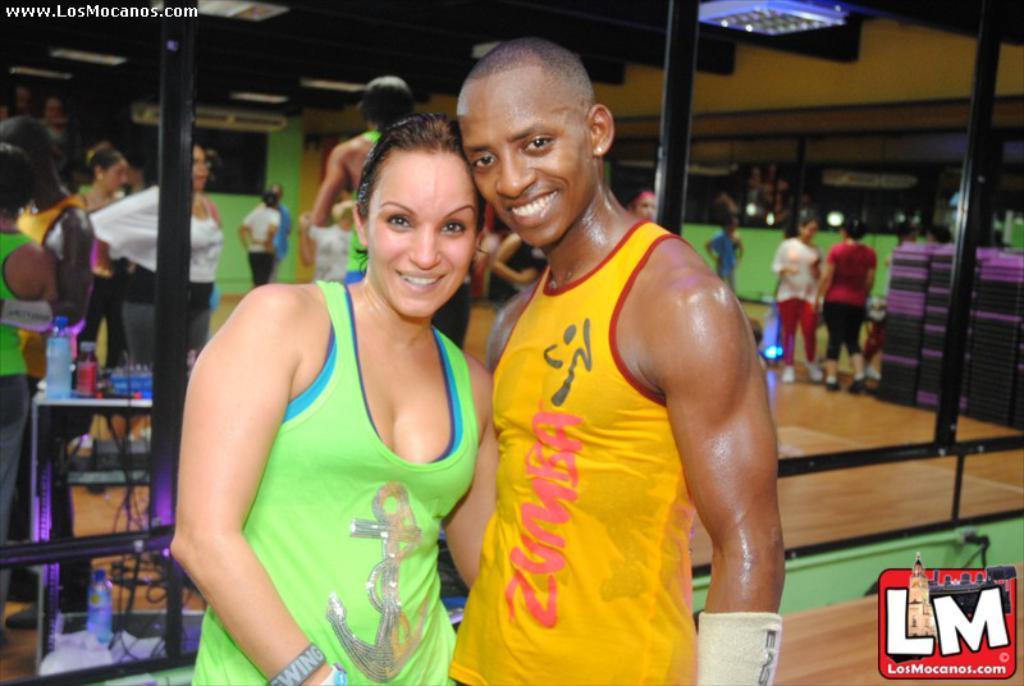Can you describe this image briefly? In the foreground of the picture we can see two persons standing. In the middle we can see mirror, in the mirror we can see the reflection of people, dance floor, mats, table, bottles, cables and various objects. At the top there are lights and ceiling. At the top left corner there is text. At the bottom right corner it is logo. 